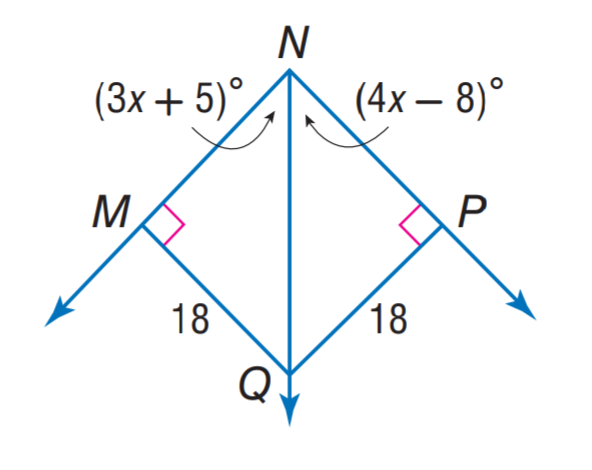Question: Find m \angle P N M.
Choices:
A. 36
B. 44
C. 63
D. 88
Answer with the letter. Answer: D 